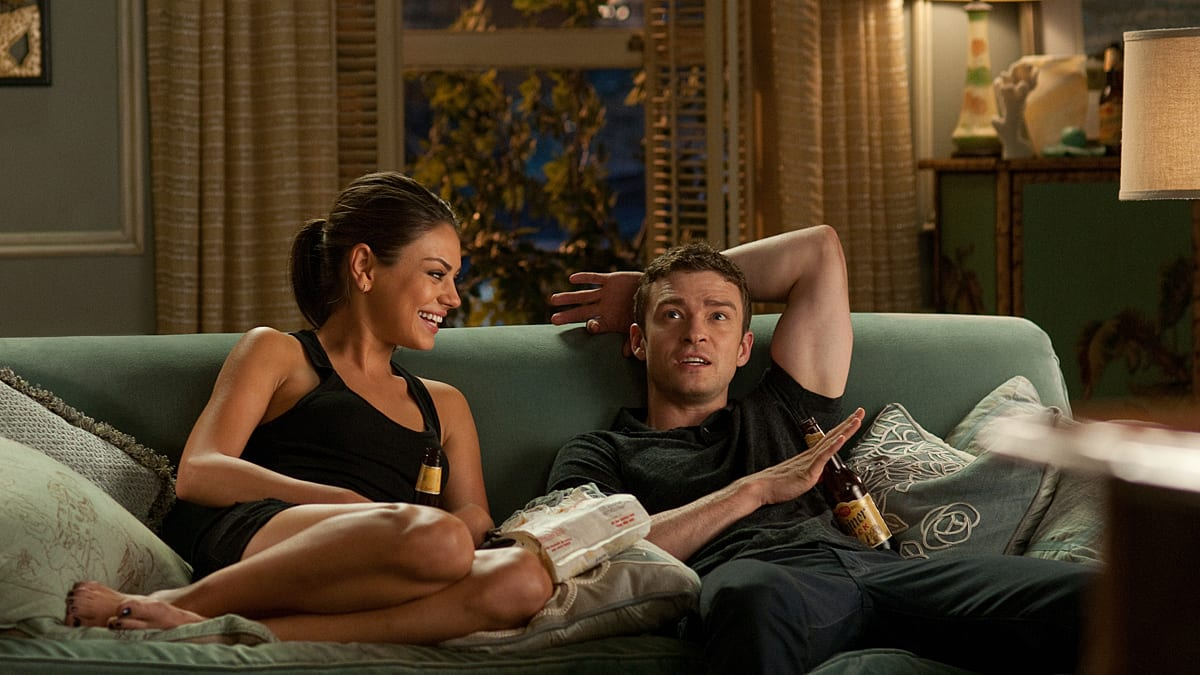Can you elaborate on the elements of the picture provided? This image captures a lively moment between two characters, portrayed by Mila Kunis and Justin Timberlake, from the romantic comedy film. In the cozy setting of a living room, Mila Kunis is seen comfortably seated on the left side of a plush green couch, sporting a relaxed outfit of a black tank top and shorts. Her posture, with crossed legs and a casual lean, alongside the cheerful beer bottle in hand, contributes to the laid-back atmosphere. She wears a bright smile, indicative of a lighthearted, engaging conversation. Opposite her, Justin Timberlake, dressed in a simple gray t-shirt and jeans, mirrors this ease. He lounges with one arm nonchalantly extended along the couch's back, his expression a mix of amusement and surprise, a beer bottle also in hand. The background details such as the patterned curtains, the traditional lamps, and the glimpse of a night scene through the window all combine to create a warm, inviting domestic scene that frames their interaction. 